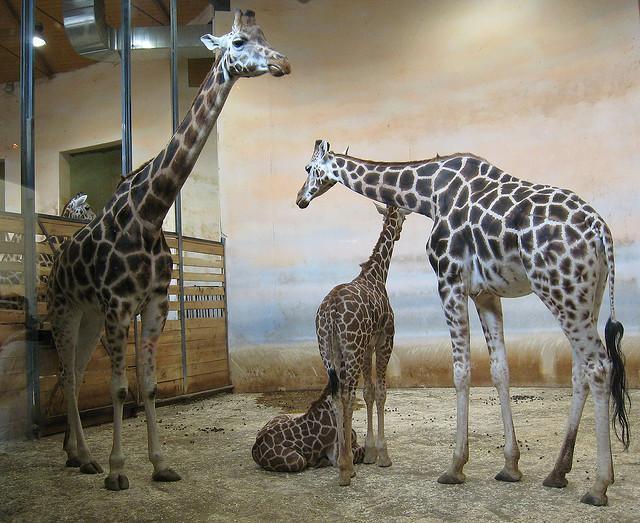What kind of venue is this?
Choose the right answer and clarify with the format: 'Answer: answer
Rationale: rationale.'
Options: Giraffe barn, zoo, wilderness, farm. Answer: giraffe barn.
Rationale: The animals have four legs and long necks. they are inside a building. 